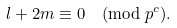<formula> <loc_0><loc_0><loc_500><loc_500>l + 2 m \equiv 0 \pmod { p ^ { c } } .</formula> 